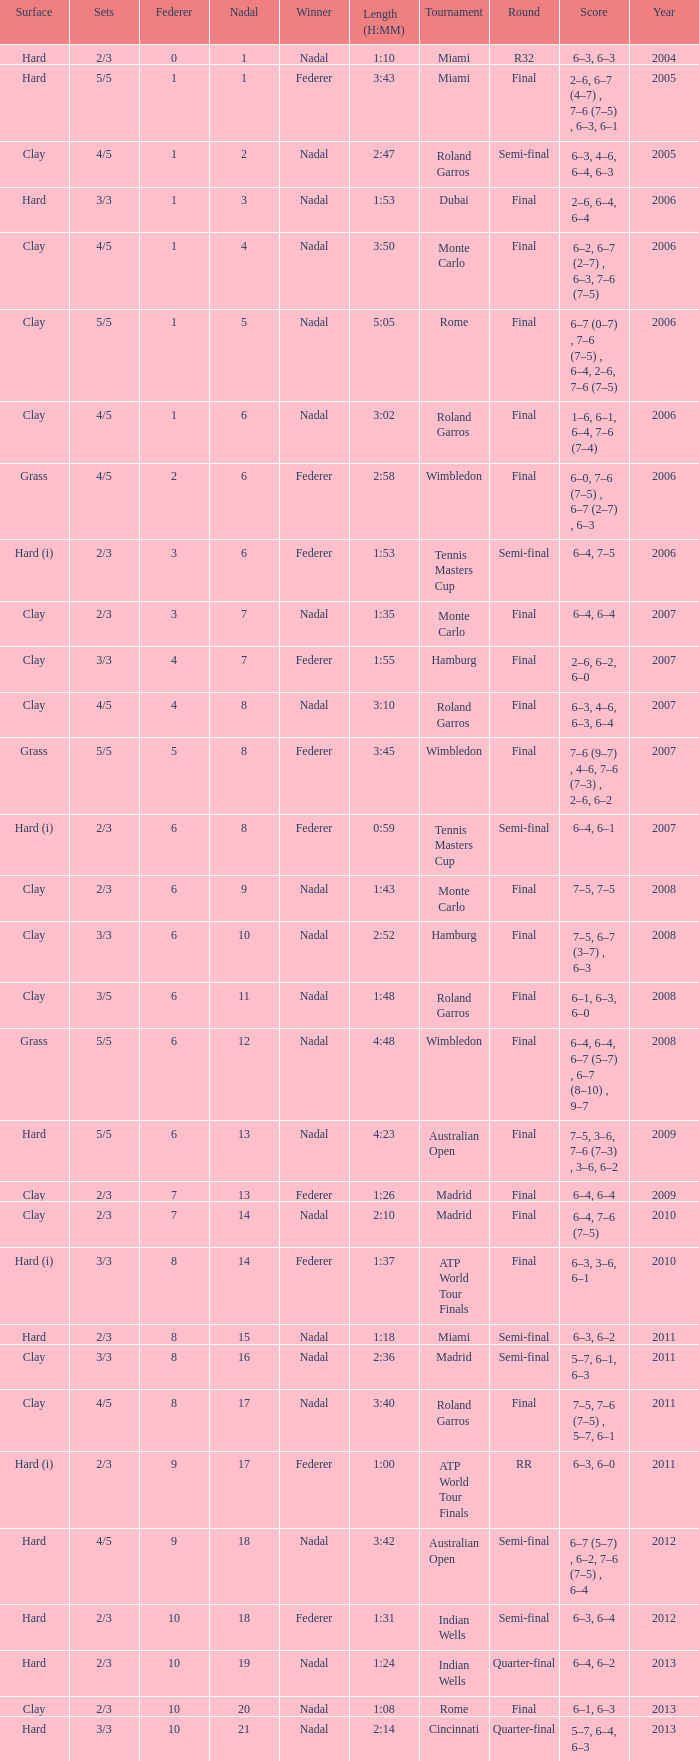What tournament did Nadal win and had a nadal of 16? Madrid. 